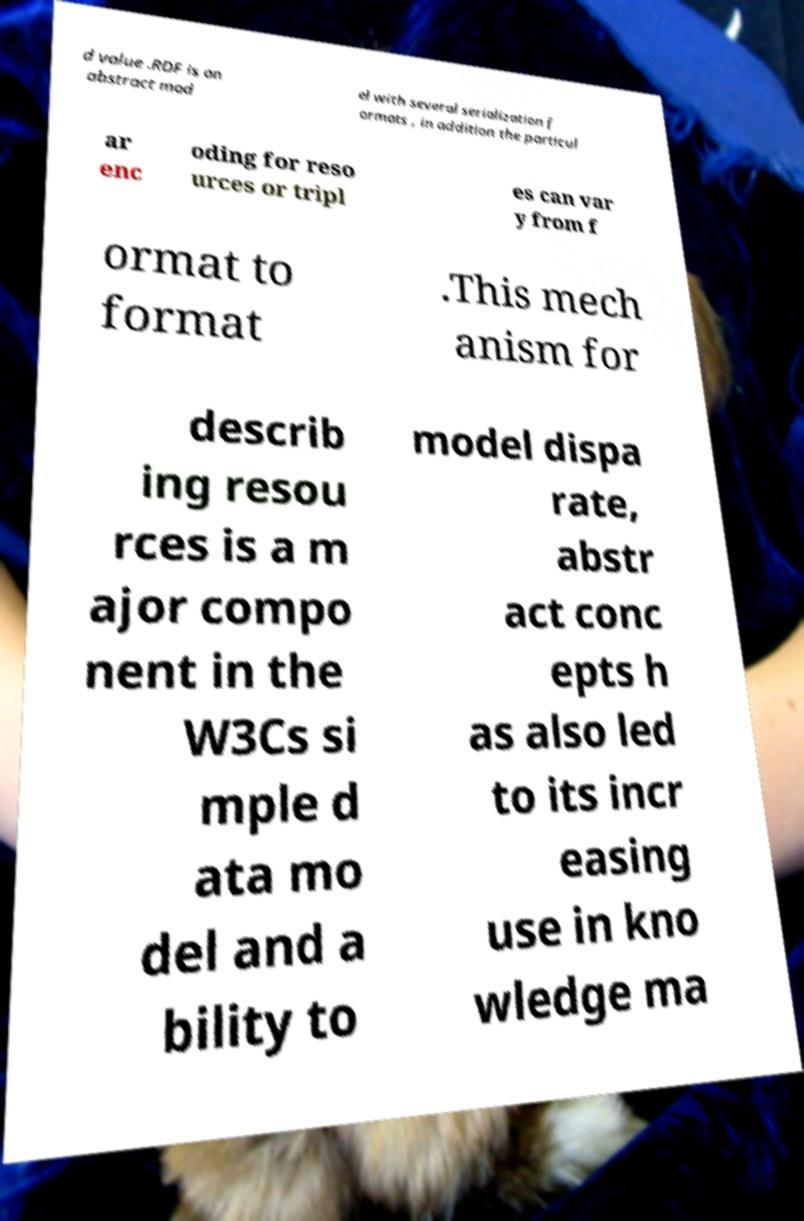For documentation purposes, I need the text within this image transcribed. Could you provide that? d value .RDF is an abstract mod el with several serialization f ormats , in addition the particul ar enc oding for reso urces or tripl es can var y from f ormat to format .This mech anism for describ ing resou rces is a m ajor compo nent in the W3Cs si mple d ata mo del and a bility to model dispa rate, abstr act conc epts h as also led to its incr easing use in kno wledge ma 